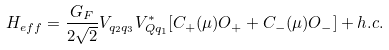<formula> <loc_0><loc_0><loc_500><loc_500>H _ { e f f } = \frac { G _ { F } } { 2 \sqrt { 2 } } V _ { q _ { 2 } q _ { 3 } } V _ { Q q _ { 1 } } ^ { * } [ C _ { + } ( \mu ) O _ { + } + C _ { - } ( \mu ) O _ { - } ] + h . c .</formula> 